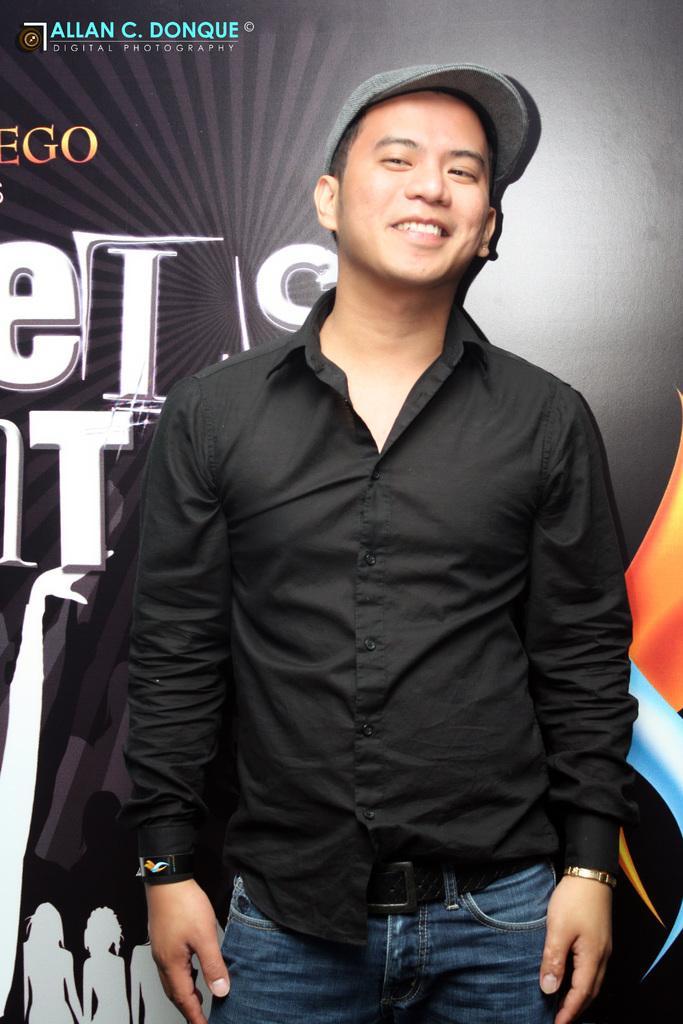In one or two sentences, can you explain what this image depicts? In this image I can see a man wearing black color shirt, standing and smiling and giving pose to the picture. In the background there is a board. 